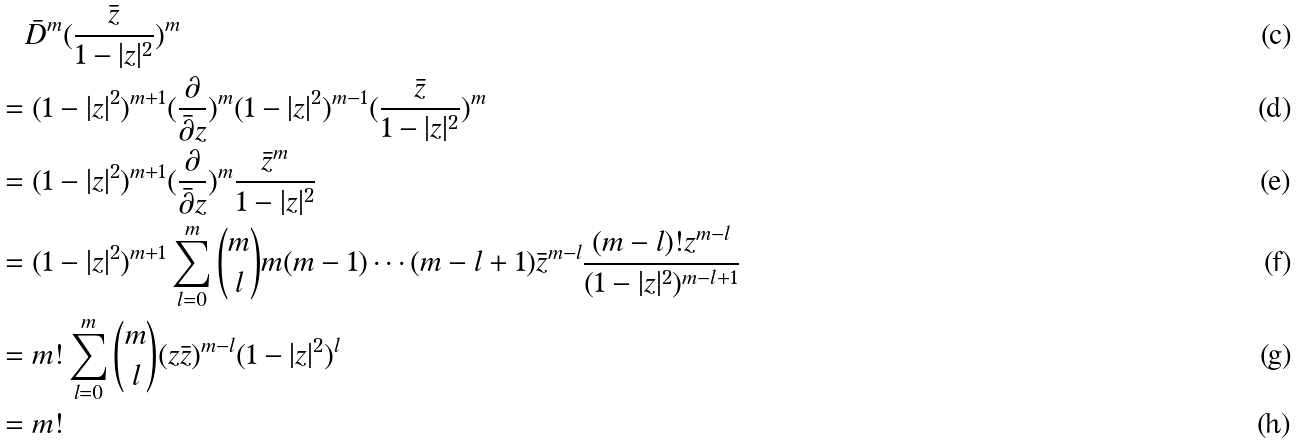<formula> <loc_0><loc_0><loc_500><loc_500>& \quad \bar { D } ^ { m } ( \frac { \bar { z } } { 1 - | z | ^ { 2 } } ) ^ { m } \\ & = ( 1 - | z | ^ { 2 } ) ^ { m + 1 } ( \frac { \partial } { \bar { \partial } z } ) ^ { m } ( 1 - | z | ^ { 2 } ) ^ { m - 1 } ( \frac { \bar { z } } { 1 - | z | ^ { 2 } } ) ^ { m } \\ & = ( 1 - | z | ^ { 2 } ) ^ { m + 1 } ( \frac { \partial } { \bar { \partial } z } ) ^ { m } \frac { \bar { z } ^ { m } } { 1 - | z | ^ { 2 } } \\ & = ( 1 - | z | ^ { 2 } ) ^ { m + 1 } \sum _ { l = 0 } ^ { m } \binom { m } { l } m ( m - 1 ) \cdots ( m - l + 1 ) \bar { z } ^ { m - l } \frac { ( m - l ) ! z ^ { m - l } } { ( 1 - | z | ^ { 2 } ) ^ { m - l + 1 } } \\ & = m ! \sum _ { l = 0 } ^ { m } \binom { m } { l } ( z \bar { z } ) ^ { m - l } ( 1 - | z | ^ { 2 } ) ^ { l } \\ & = m !</formula> 